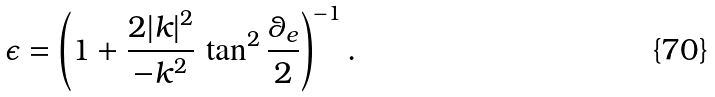Convert formula to latex. <formula><loc_0><loc_0><loc_500><loc_500>\epsilon = \left ( 1 + \frac { 2 | { k } | ^ { 2 } } { - k ^ { 2 } } \, \tan ^ { 2 } \frac { \theta _ { e } } { 2 } \right ) ^ { - 1 } .</formula> 